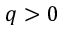<formula> <loc_0><loc_0><loc_500><loc_500>q > 0</formula> 